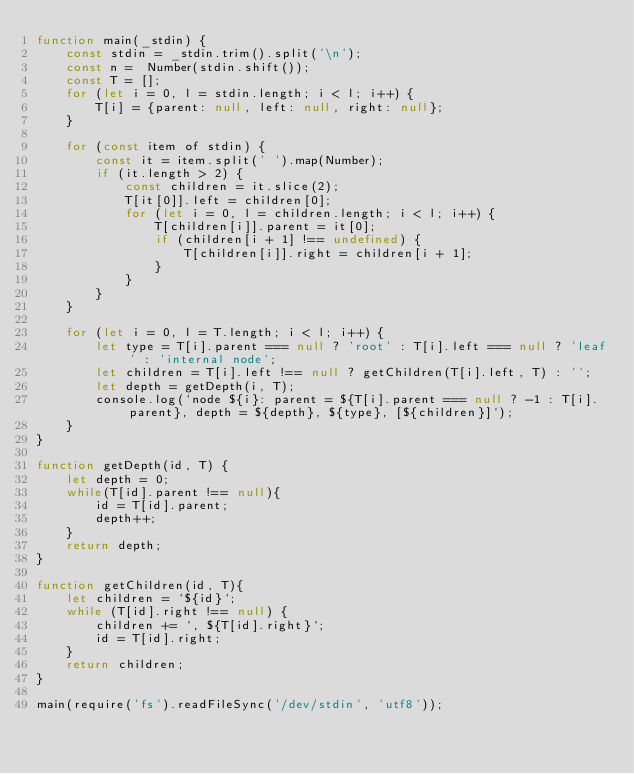<code> <loc_0><loc_0><loc_500><loc_500><_JavaScript_>function main(_stdin) {
    const stdin = _stdin.trim().split('\n');
    const n =  Number(stdin.shift());
    const T = [];
    for (let i = 0, l = stdin.length; i < l; i++) {
        T[i] = {parent: null, left: null, right: null};
    }

    for (const item of stdin) {
        const it = item.split(' ').map(Number);
        if (it.length > 2) {
            const children = it.slice(2);
            T[it[0]].left = children[0];
            for (let i = 0, l = children.length; i < l; i++) {
                T[children[i]].parent = it[0];
                if (children[i + 1] !== undefined) {
                    T[children[i]].right = children[i + 1];
                }
            }
        }
    }

    for (let i = 0, l = T.length; i < l; i++) {
        let type = T[i].parent === null ? 'root' : T[i].left === null ? 'leaf' : 'internal node';
        let children = T[i].left !== null ? getChildren(T[i].left, T) : '';
        let depth = getDepth(i, T);
        console.log(`node ${i}: parent = ${T[i].parent === null ? -1 : T[i].parent}, depth = ${depth}, ${type}, [${children}]`);
    }
}

function getDepth(id, T) {
    let depth = 0;
    while(T[id].parent !== null){
        id = T[id].parent;
        depth++;
    }
    return depth;
}

function getChildren(id, T){
    let children = `${id}`;
    while (T[id].right !== null) {
        children += `, ${T[id].right}`;
        id = T[id].right;
    }
    return children;
}

main(require('fs').readFileSync('/dev/stdin', 'utf8'));

</code> 